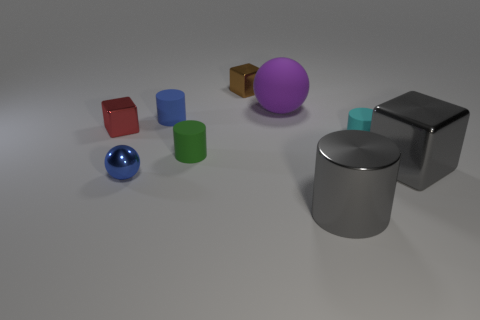Subtract all cylinders. How many objects are left? 5 Subtract all tiny green cubes. Subtract all big metallic things. How many objects are left? 7 Add 7 tiny blue shiny objects. How many tiny blue shiny objects are left? 8 Add 4 matte spheres. How many matte spheres exist? 5 Subtract 0 green spheres. How many objects are left? 9 